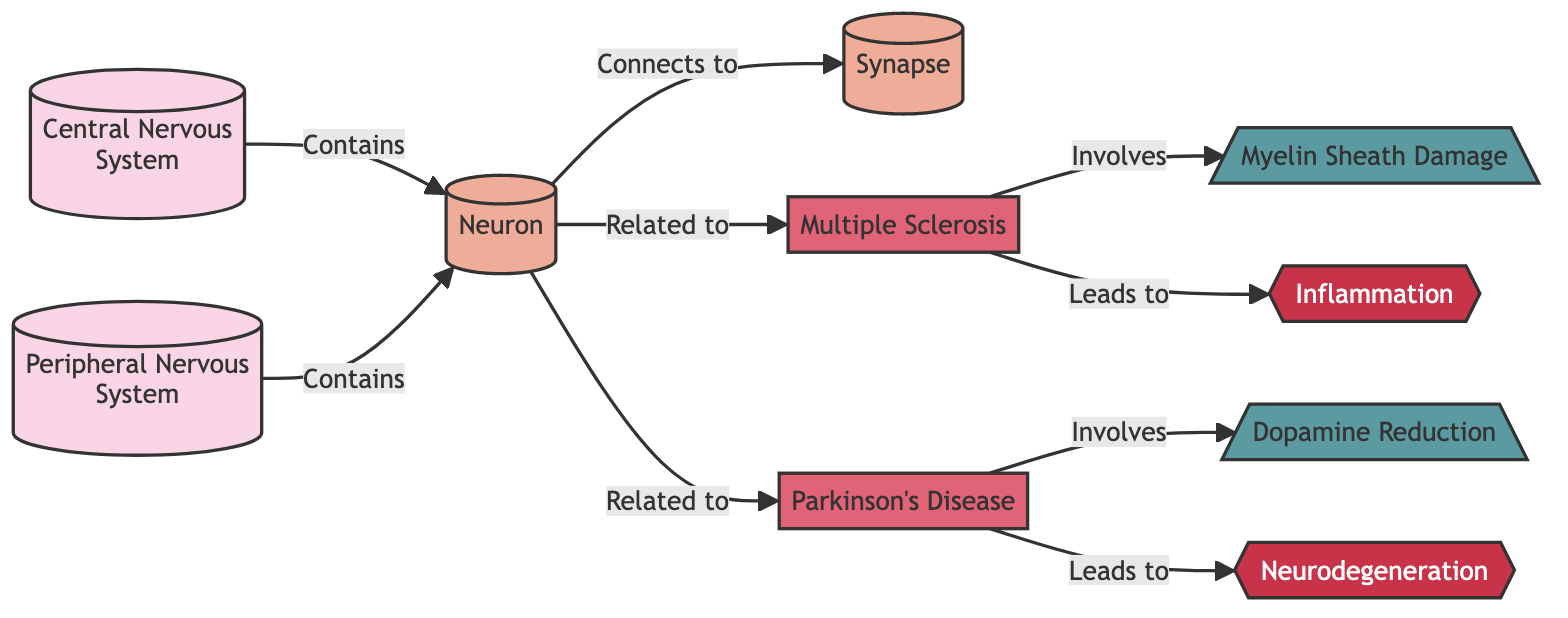What are the two parts of the nervous system depicted in the diagram? The diagram shows two parts of the nervous system: the Central Nervous System and the Peripheral Nervous System, indicated as distinct nodes.
Answer: Central Nervous System and Peripheral Nervous System Which neurological disorder is related to neuronal inflammation? The diagram indicates a direct connection between Multiple Sclerosis and Inflammation, meaning Multiple Sclerosis is related to neuronal inflammation as depicted in the relationships.
Answer: Multiple Sclerosis How many disorders are represented in the diagram? The diagram identifies two disorders, Multiple Sclerosis and Parkinson's Disease, as nodes labeled as disorder, thus totaling two.
Answer: 2 What is the mechanism involved in Parkinson's Disease? According to the diagram, Parkinson's Disease is associated with the "Dopamine Reduction" mechanism, indicated by the connection from Parkinson's Disease to the mechanism node.
Answer: Dopamine Reduction Which disorder leads to neurodegeneration? The diagram shows that Parkinson's Disease leads to Neurodegeneration, as indicated by the directional flow from Parkinson's Disease to the Neurodegeneration pathway.
Answer: Parkinson's Disease What type of pathway is associated with Multiple Sclerosis? The diagram indicates that Multiple Sclerosis leads to an Inflammation pathway, which is categorized as a pathway type in the diagram.
Answer: Inflammation How many mechanisms are listed in the diagram? The diagram features two mechanisms: "Dopamine Reduction" and "Myelin Sheath Damage," making a total of two mechanisms.
Answer: 2 What node type is "Neuron" classified as in the diagram? The diagram classifies "Neuron" as a component type, which can be recognized by its specific styling as indicated in the node definitions section.
Answer: Component Which component connects to the synapse? The diagram shows that the Neuron connects to the Synapse, illustrating a direct connection from the Neuron node to the Synapse node.
Answer: Neuron 